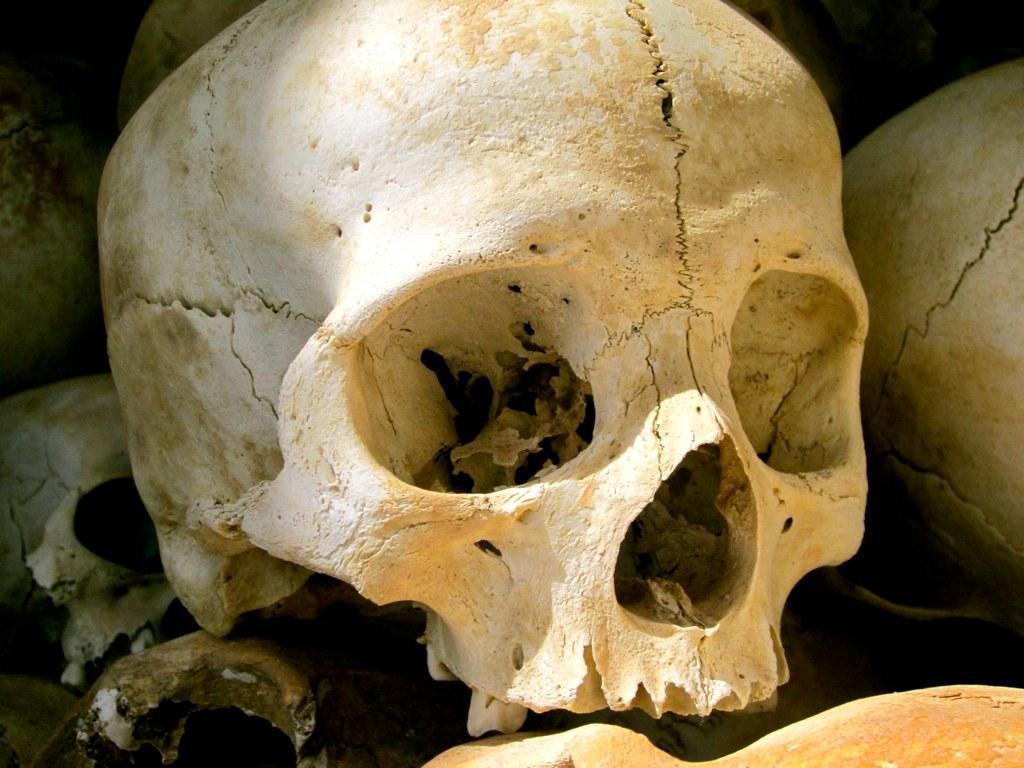Describe this image in one or two sentences. In this picture I can observe number of skulls. I can observe cracks on the skulls. These are in white color. 